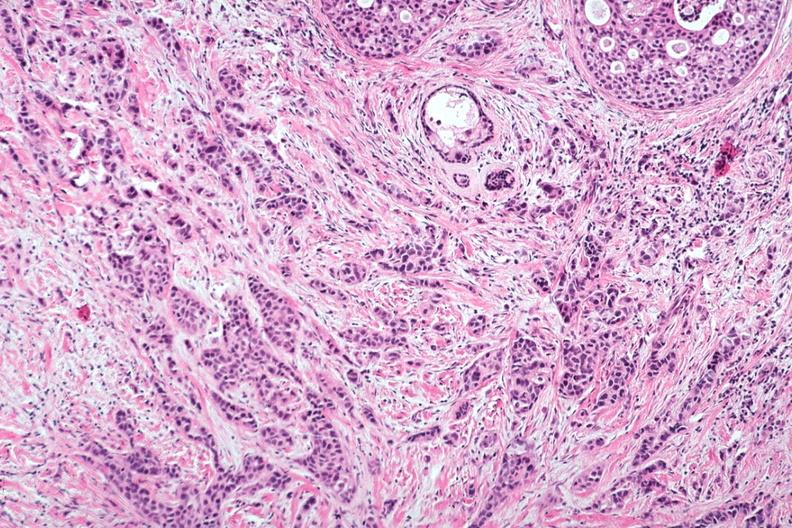re intraductal lesions seen?
Answer the question using a single word or phrase. Yes 